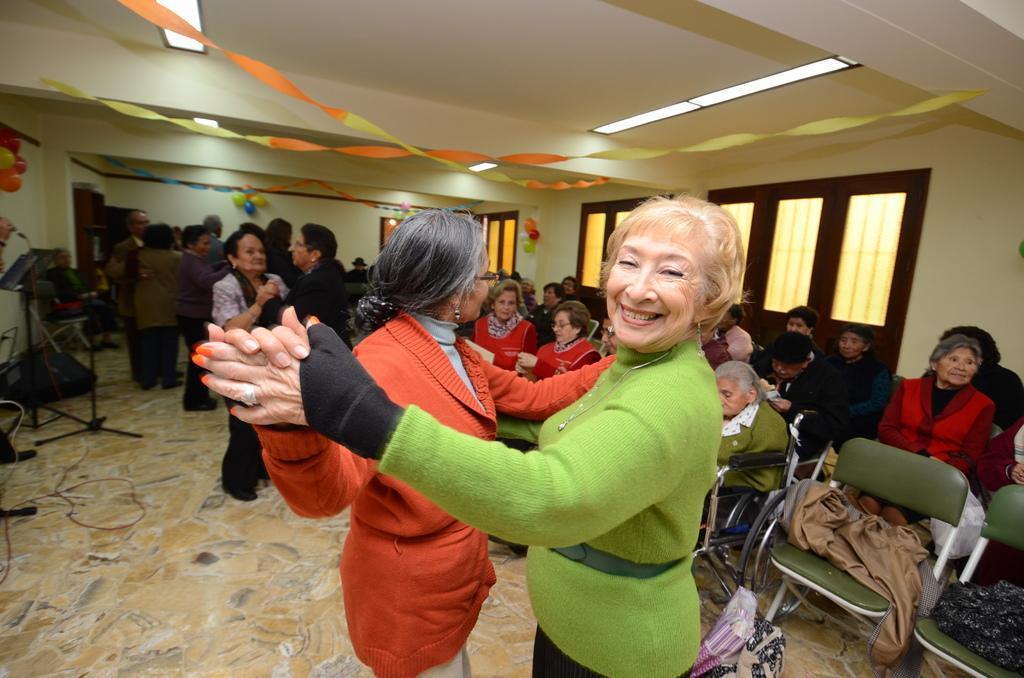How would you summarize this image in a sentence or two? In this picture I can see group of people dancing, there are group of people sitting on the chairs, there are lights, balloons, paper ribbons, there are windows and some other objects. 